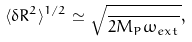<formula> <loc_0><loc_0><loc_500><loc_500>\langle \delta R ^ { 2 } \rangle ^ { 1 / 2 } \simeq \sqrt { \frac { } { 2 M _ { P } \omega _ { e x t } } } ,</formula> 